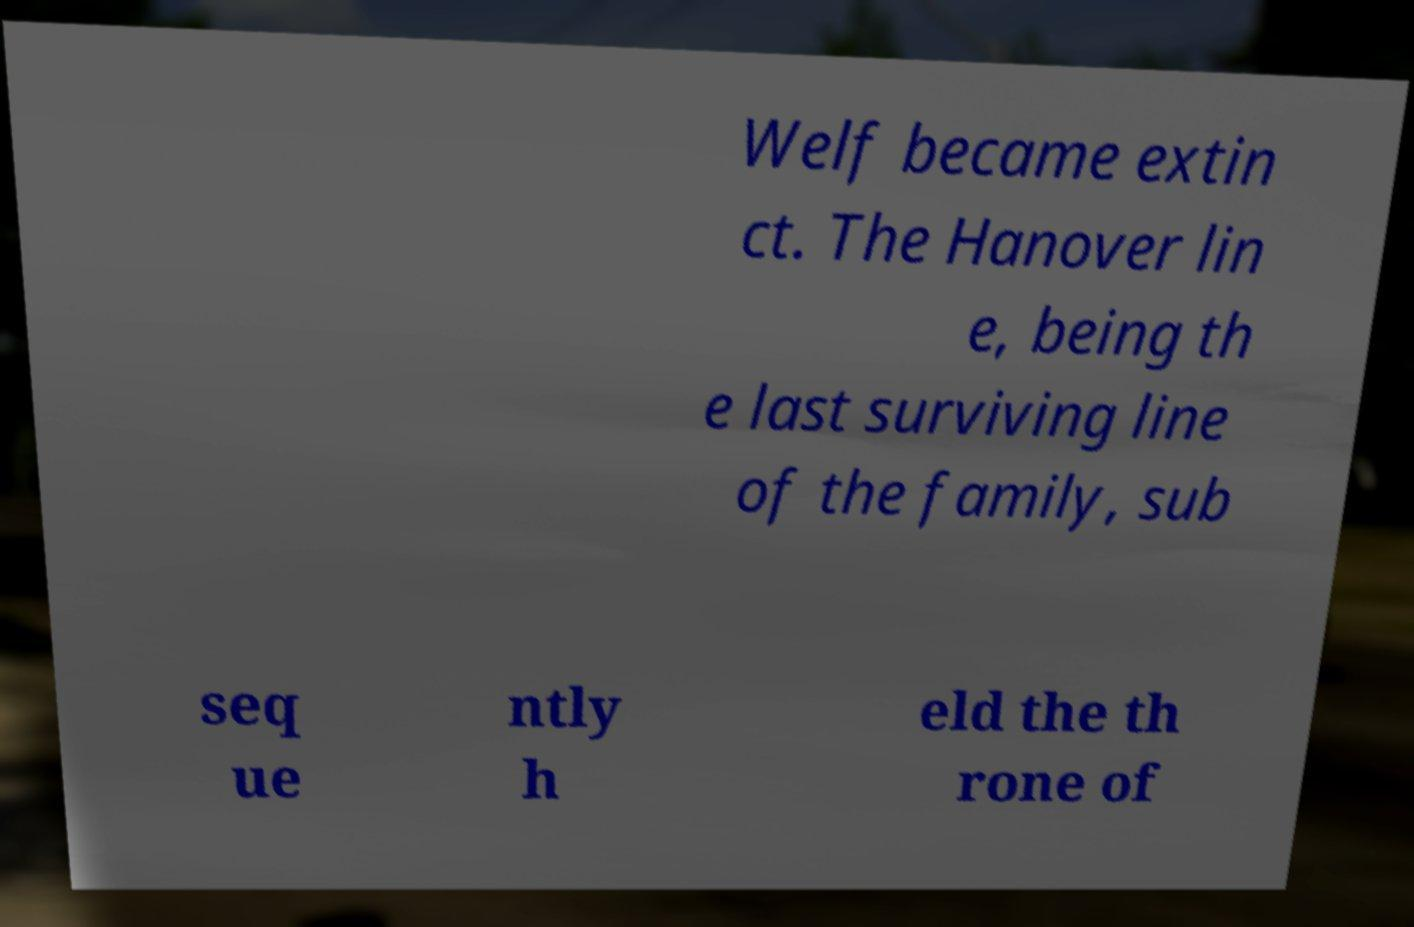Could you extract and type out the text from this image? Welf became extin ct. The Hanover lin e, being th e last surviving line of the family, sub seq ue ntly h eld the th rone of 